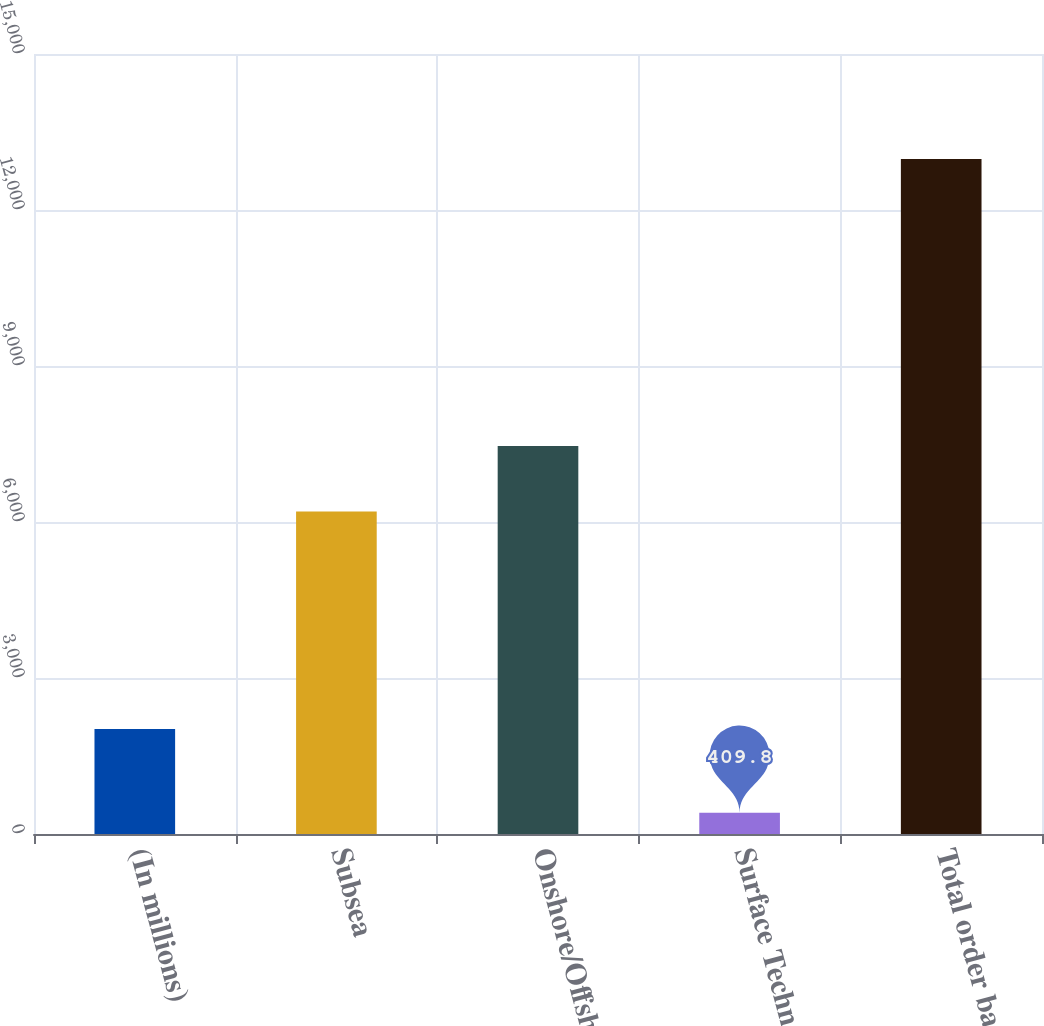Convert chart. <chart><loc_0><loc_0><loc_500><loc_500><bar_chart><fcel>(In millions)<fcel>Subsea<fcel>Onshore/Offshore<fcel>Surface Technologies<fcel>Total order backlog<nl><fcel>2017<fcel>6203.9<fcel>7461.2<fcel>409.8<fcel>12982.8<nl></chart> 